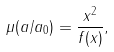Convert formula to latex. <formula><loc_0><loc_0><loc_500><loc_500>\mu ( a / a _ { 0 } ) = \frac { x ^ { 2 } } { f ( x ) } ,</formula> 